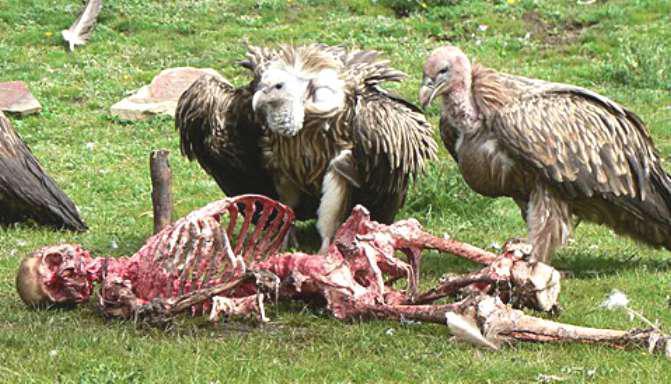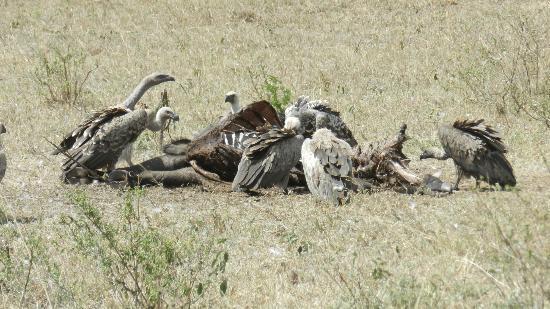The first image is the image on the left, the second image is the image on the right. Analyze the images presented: Is the assertion "The left image contains exactly two vultures." valid? Answer yes or no. Yes. 